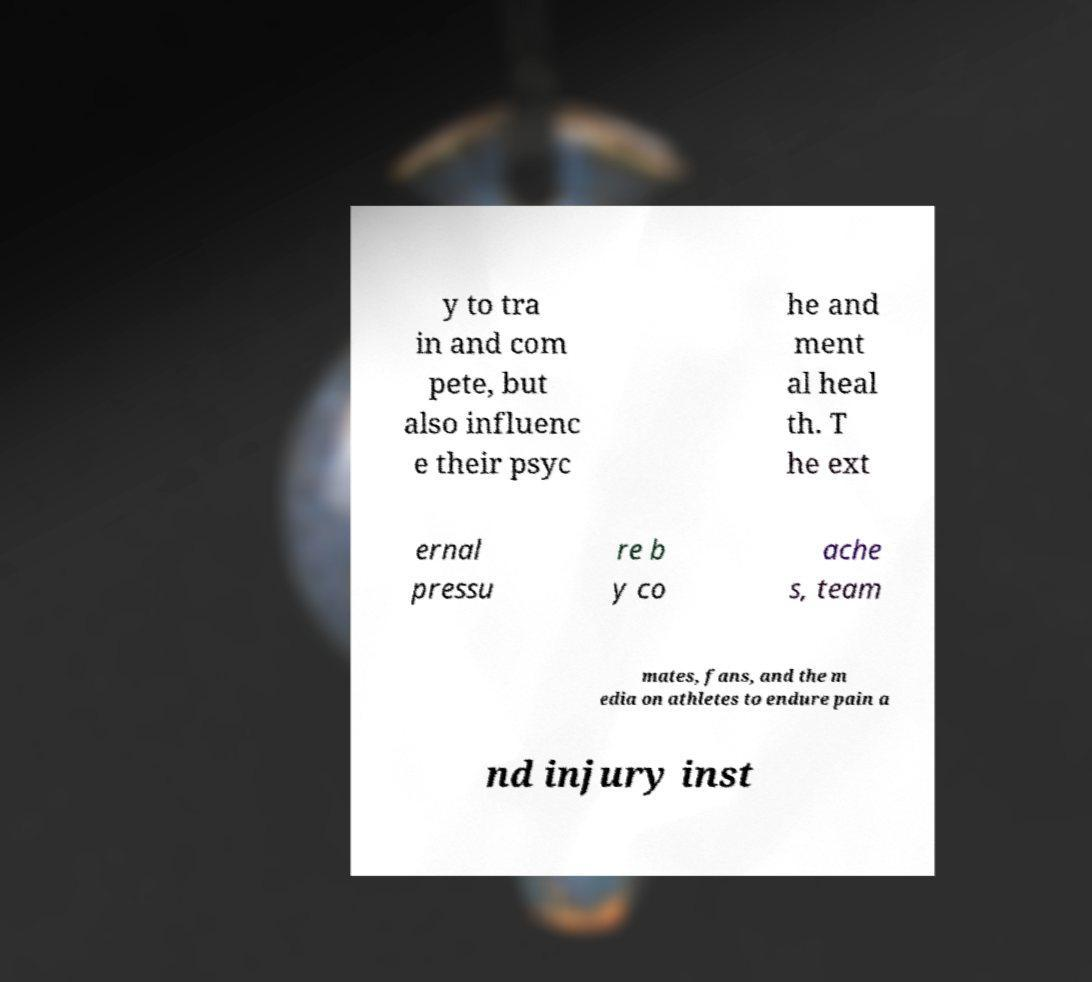Please read and relay the text visible in this image. What does it say? y to tra in and com pete, but also influenc e their psyc he and ment al heal th. T he ext ernal pressu re b y co ache s, team mates, fans, and the m edia on athletes to endure pain a nd injury inst 